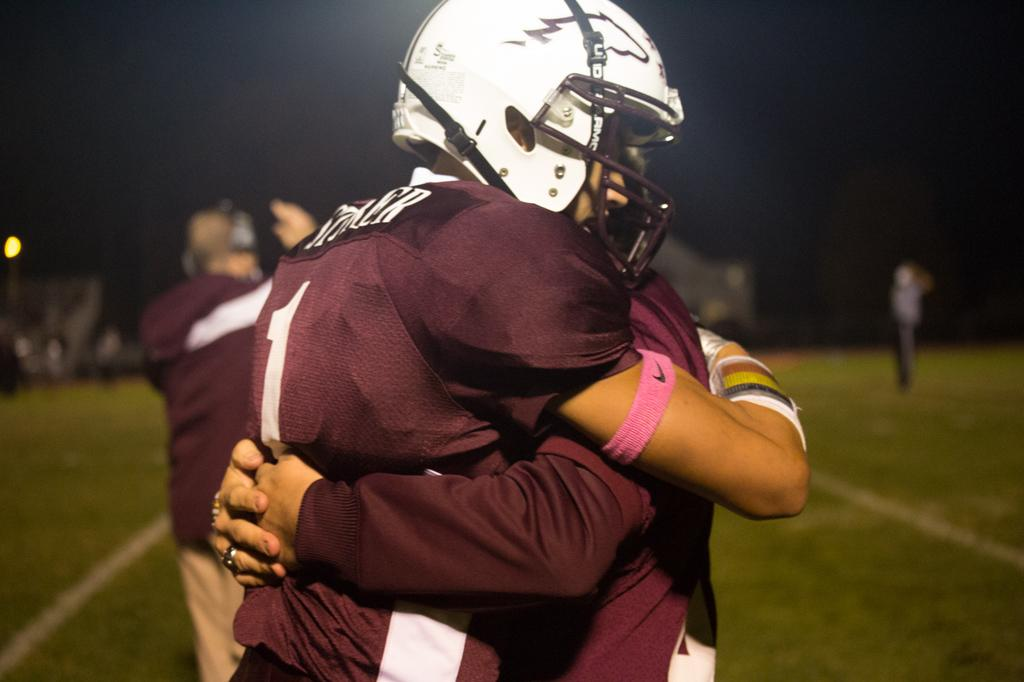How many people are in the image? There are two persons in the image. What are the persons wearing? The persons are wearing clothes. What are the persons doing in the image? The persons are hugging. Can you describe the background of the image? The background of the image is blurred. What invention can be seen in the hands of the persons in the image? There is no invention visible in the hands of the persons in the image; they are simply hugging. Is there a sheep present in the image? No, there is no sheep present in the image. 